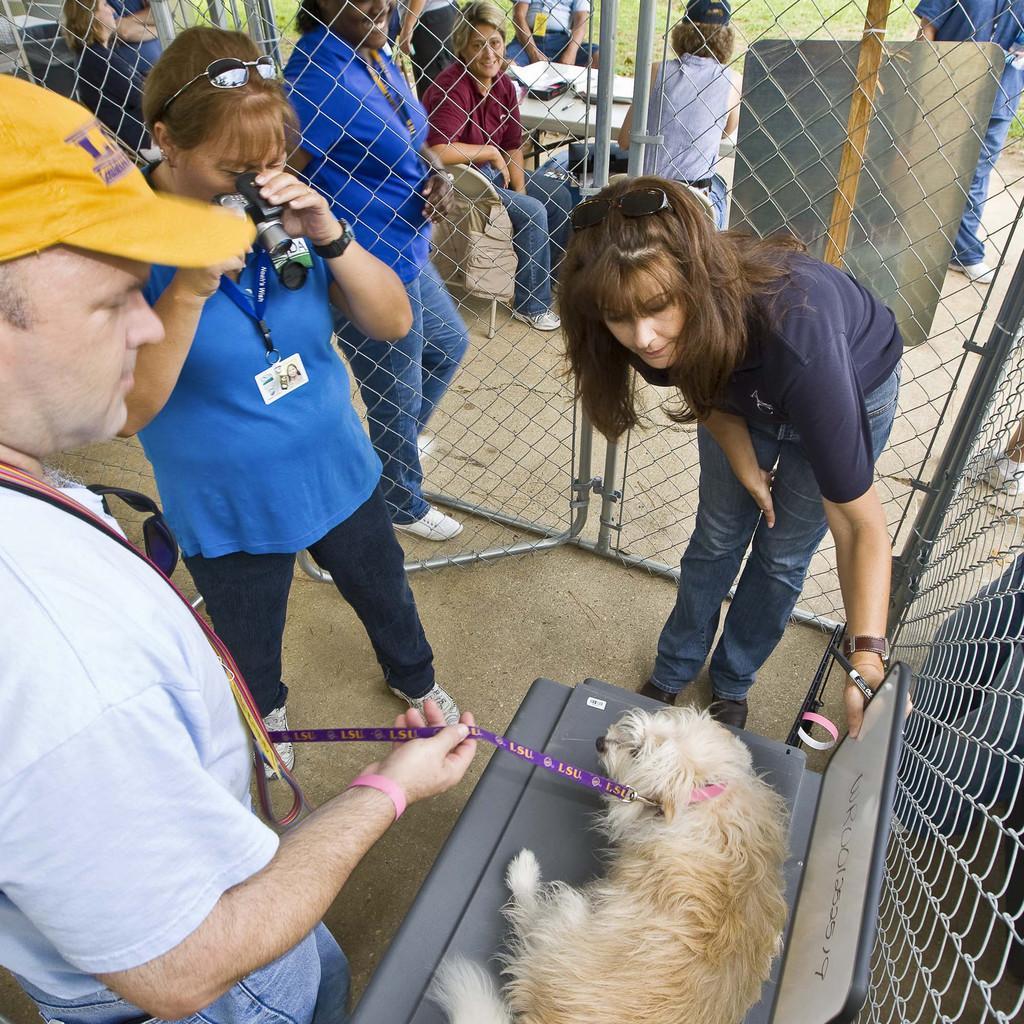In one or two sentences, can you explain what this image depicts? In this picture we can see three people standing around the chair on which there is a dog. 